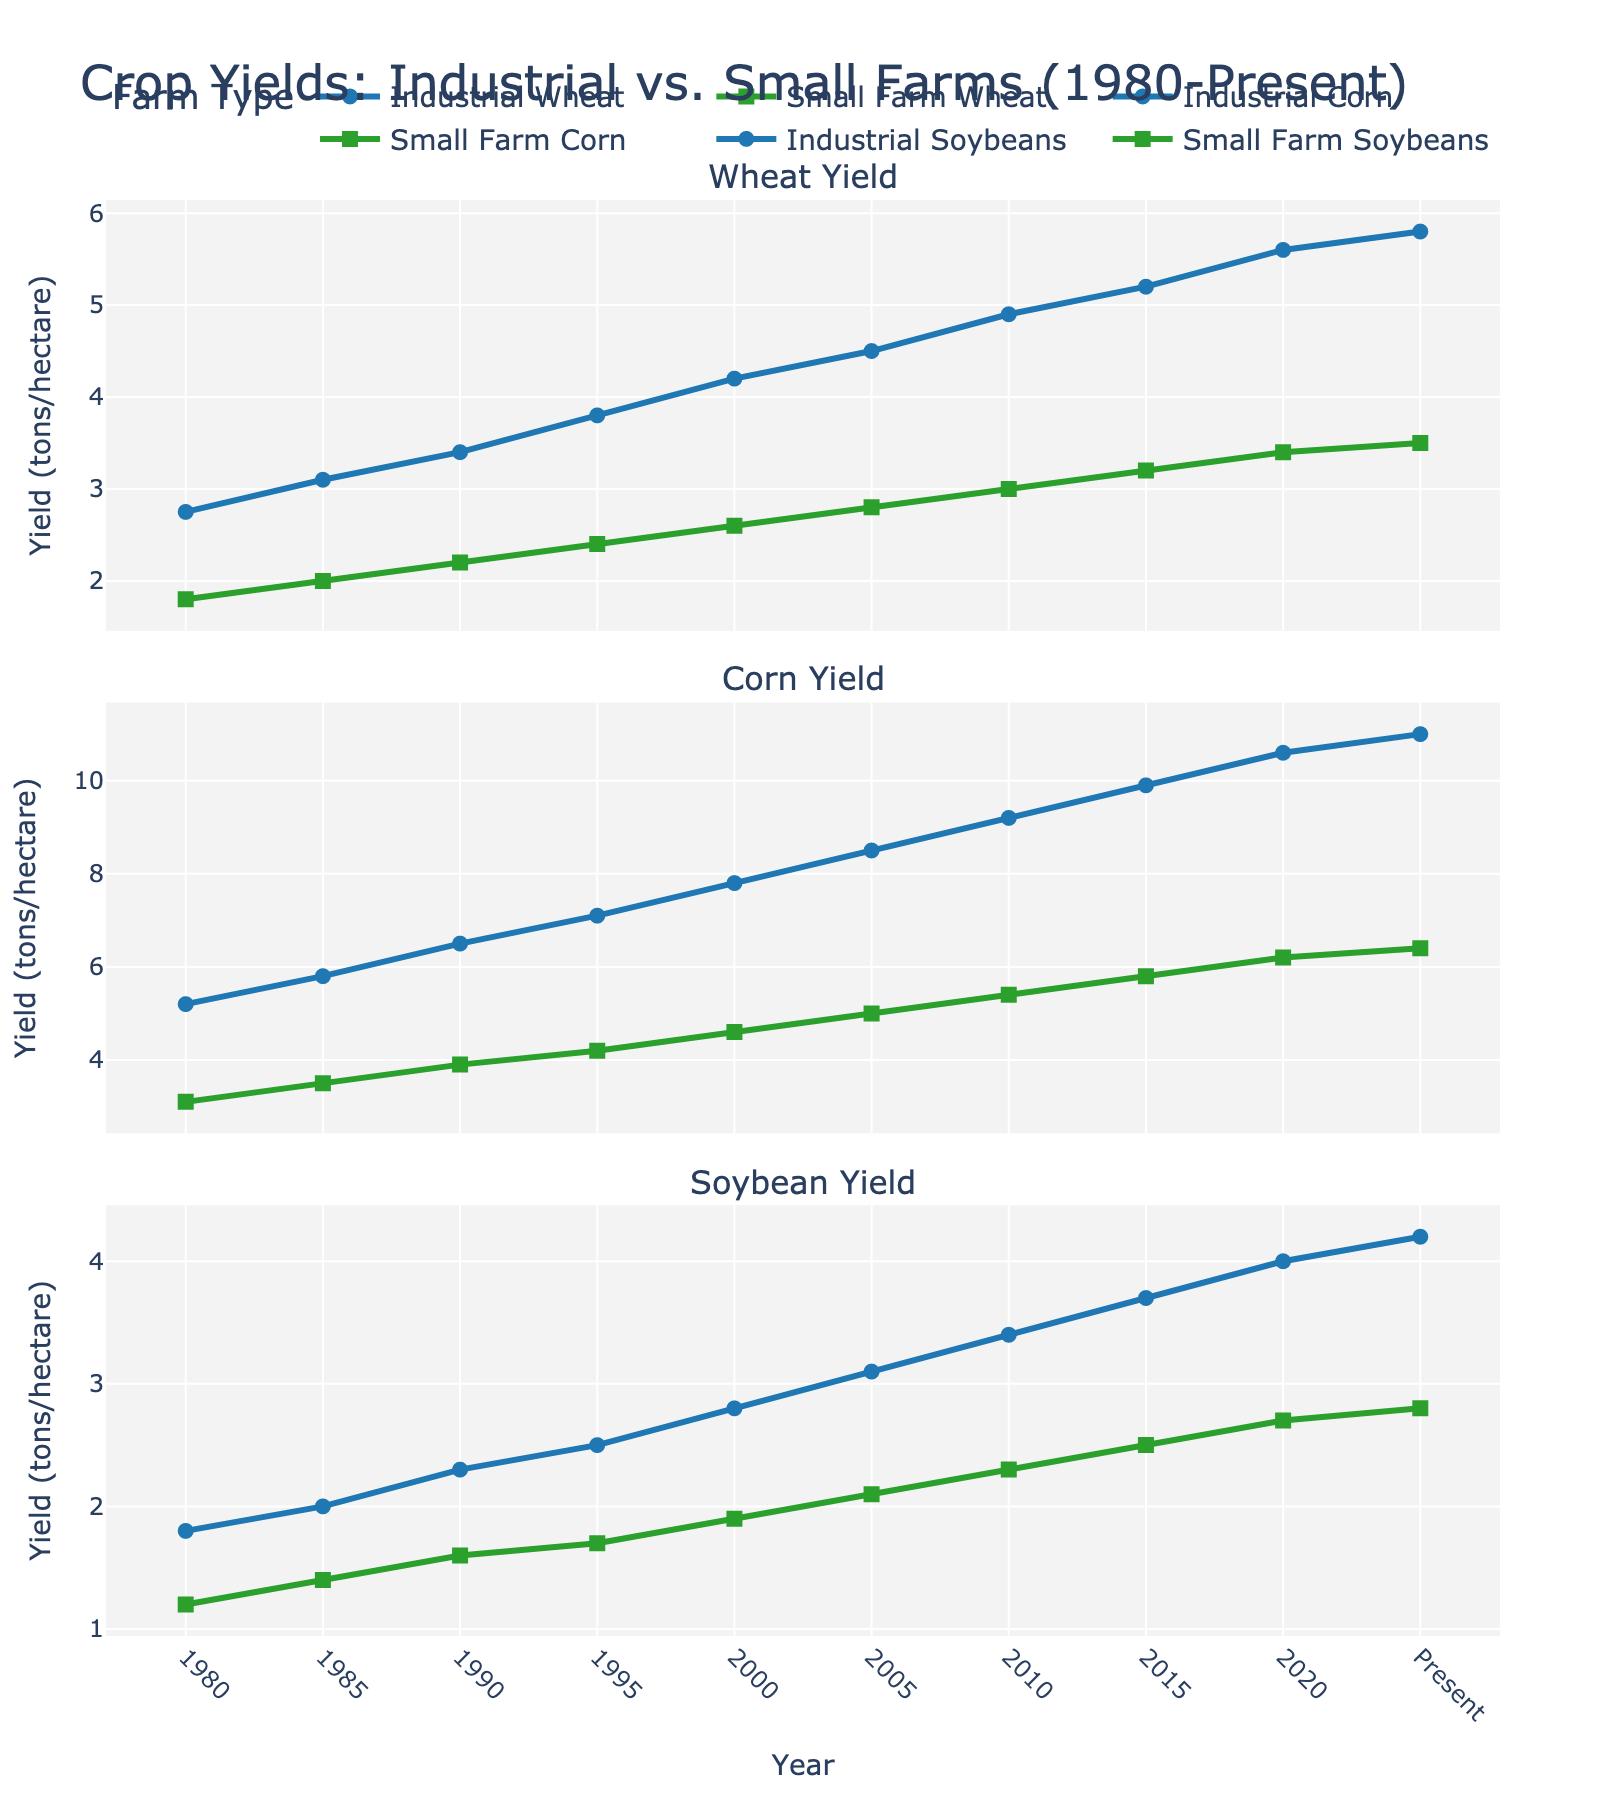What are the wheat yields for small farms and industrial farms in 2020? Locate the data points for 2020 on the 'Wheat Yield' subplot. The small farm wheat yield is represented by the square marker, and the industrial farm wheat yield is represented by the circle marker.
Answer: 3.4 tons/hectare and 5.6 tons/hectare How has the yield gap between industrial and small farms for corn changed from 1980 to the present? In 1980, the yield gap (difference) for corn between industrial and small farms is 5.2 - 3.1 = 2.1. In the present, the yield gap is 11.0 - 6.4 = 4.6. Comparatively, the yield gap has increased by 4.6 - 2.1 = 2.5.
Answer: Increased by 2.5 tons/hectare Which crop shows the highest yield for industrial farms in the present year? Look at the present year's data points for all three crops (Wheat, Corn, Soybeans) for industrial farms: wheat (5.8), corn (11.0), soybeans (4.2). The highest yield is for corn.
Answer: Corn Compare the growth in soybean yields for small farms versus industrial farms from 1980 to the present. Calculate the difference in yield from 1980 to the present for both farm types. Small farms: 2.8 - 1.2 = 1.6. Industrial farms: 4.2 - 1.8 = 2.4.
Answer: Industrial farms grew by 2.4 tons/hectare, small farms by 1.6 tons/hectare What's the average wheat yield for industrial farms from 1980 to the present? Sum up the wheat yields for industrial farms from 1980 to the present (2.75 + 3.1 + 3.4 + 3.8 + 4.2 + 4.5 + 4.9 + 5.2 + 5.6 + 5.8) = 43.5. There are 10 data points, so the average yield is 43.5/10 = 4.35.
Answer: 4.35 tons/hectare Which farm type has shown a greater increase in corn yield from 2000 to 2020? Calculate the increase for both farm types. Small farms: 6.2 - 4.6 = 1.6. Industrial farms: 10.6 - 7.8 = 2.8.
Answer: Industrial farms What is the overall trend in soybean yields for small farms through the years? Analyze the 'Soybean Yield' subplot for small farms, noting the increase from 1.2 in 1980 to 2.8 in the present. The trend shows a steady increase over the years.
Answer: Steadily increasing How do the yields of small farm corn compare to industrial farm corn in 1995? Check the 'Corn Yield' subplot for 1995. Small farm yield is 4.2, and industrial farm yield is 7.1. Compare these values directly.
Answer: Industrial farm corn yield is higher Calculate the total yield of wheat for industrial farms in the years 1990 and 2000 combined. Add the wheat yields for industrial farms in 1990 and 2000: 3.4 + 4.2 = 7.6.
Answer: 7.6 tons/hectare What visual attribute helps differentiate between data for industrial and small farms on the line chart? The markers’ shape helps differentiate: circles for industrial farms and squares for small farms. The color is also different, with industrial farms in blue and small farms in green.
Answer: Marker shapes and colors 